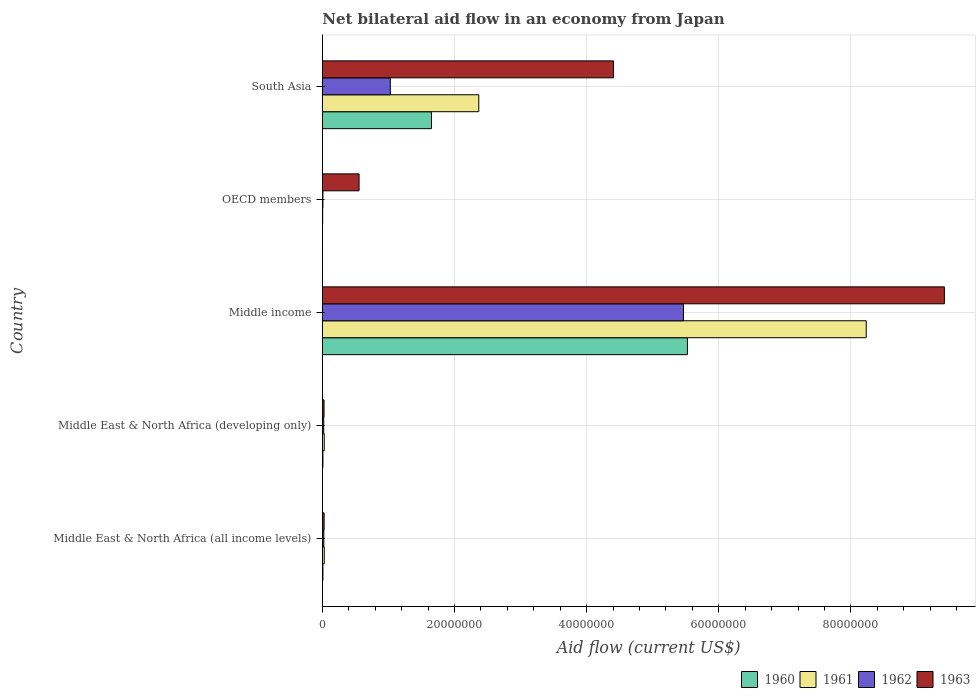How many groups of bars are there?
Keep it short and to the point. 5. Are the number of bars per tick equal to the number of legend labels?
Offer a very short reply. Yes. Are the number of bars on each tick of the Y-axis equal?
Keep it short and to the point. Yes. What is the label of the 4th group of bars from the top?
Give a very brief answer. Middle East & North Africa (developing only). Across all countries, what is the maximum net bilateral aid flow in 1963?
Your response must be concise. 9.42e+07. In which country was the net bilateral aid flow in 1960 maximum?
Give a very brief answer. Middle income. In which country was the net bilateral aid flow in 1963 minimum?
Give a very brief answer. Middle East & North Africa (developing only). What is the total net bilateral aid flow in 1962 in the graph?
Make the answer very short. 6.55e+07. What is the difference between the net bilateral aid flow in 1962 in Middle East & North Africa (all income levels) and that in Middle income?
Offer a terse response. -5.44e+07. What is the difference between the net bilateral aid flow in 1963 in OECD members and the net bilateral aid flow in 1960 in Middle income?
Provide a short and direct response. -4.97e+07. What is the average net bilateral aid flow in 1963 per country?
Offer a terse response. 2.89e+07. What is the difference between the net bilateral aid flow in 1960 and net bilateral aid flow in 1961 in Middle income?
Give a very brief answer. -2.71e+07. In how many countries, is the net bilateral aid flow in 1962 greater than 36000000 US$?
Offer a very short reply. 1. What is the ratio of the net bilateral aid flow in 1961 in Middle East & North Africa (developing only) to that in Middle income?
Keep it short and to the point. 0. Is the net bilateral aid flow in 1962 in Middle East & North Africa (all income levels) less than that in Middle income?
Keep it short and to the point. Yes. What is the difference between the highest and the second highest net bilateral aid flow in 1960?
Your response must be concise. 3.87e+07. What is the difference between the highest and the lowest net bilateral aid flow in 1963?
Provide a succinct answer. 9.39e+07. Is the sum of the net bilateral aid flow in 1963 in Middle income and OECD members greater than the maximum net bilateral aid flow in 1960 across all countries?
Your answer should be compact. Yes. Is it the case that in every country, the sum of the net bilateral aid flow in 1960 and net bilateral aid flow in 1961 is greater than the net bilateral aid flow in 1962?
Give a very brief answer. No. Does the graph contain grids?
Provide a succinct answer. Yes. Where does the legend appear in the graph?
Your response must be concise. Bottom right. How many legend labels are there?
Give a very brief answer. 4. What is the title of the graph?
Keep it short and to the point. Net bilateral aid flow in an economy from Japan. Does "1995" appear as one of the legend labels in the graph?
Provide a short and direct response. No. What is the label or title of the X-axis?
Offer a very short reply. Aid flow (current US$). What is the Aid flow (current US$) of 1960 in Middle East & North Africa (all income levels)?
Offer a terse response. 9.00e+04. What is the Aid flow (current US$) in 1961 in Middle East & North Africa (all income levels)?
Make the answer very short. 2.90e+05. What is the Aid flow (current US$) in 1962 in Middle East & North Africa (all income levels)?
Offer a terse response. 2.30e+05. What is the Aid flow (current US$) in 1963 in Middle East & North Africa (all income levels)?
Keep it short and to the point. 2.70e+05. What is the Aid flow (current US$) of 1962 in Middle East & North Africa (developing only)?
Provide a succinct answer. 2.10e+05. What is the Aid flow (current US$) of 1963 in Middle East & North Africa (developing only)?
Offer a terse response. 2.60e+05. What is the Aid flow (current US$) in 1960 in Middle income?
Give a very brief answer. 5.53e+07. What is the Aid flow (current US$) of 1961 in Middle income?
Give a very brief answer. 8.23e+07. What is the Aid flow (current US$) of 1962 in Middle income?
Provide a succinct answer. 5.47e+07. What is the Aid flow (current US$) in 1963 in Middle income?
Give a very brief answer. 9.42e+07. What is the Aid flow (current US$) in 1960 in OECD members?
Your response must be concise. 3.00e+04. What is the Aid flow (current US$) of 1963 in OECD members?
Offer a terse response. 5.56e+06. What is the Aid flow (current US$) of 1960 in South Asia?
Provide a short and direct response. 1.65e+07. What is the Aid flow (current US$) in 1961 in South Asia?
Provide a succinct answer. 2.37e+07. What is the Aid flow (current US$) of 1962 in South Asia?
Make the answer very short. 1.03e+07. What is the Aid flow (current US$) in 1963 in South Asia?
Keep it short and to the point. 4.41e+07. Across all countries, what is the maximum Aid flow (current US$) in 1960?
Keep it short and to the point. 5.53e+07. Across all countries, what is the maximum Aid flow (current US$) in 1961?
Make the answer very short. 8.23e+07. Across all countries, what is the maximum Aid flow (current US$) of 1962?
Your response must be concise. 5.47e+07. Across all countries, what is the maximum Aid flow (current US$) of 1963?
Ensure brevity in your answer.  9.42e+07. Across all countries, what is the minimum Aid flow (current US$) of 1962?
Ensure brevity in your answer.  9.00e+04. Across all countries, what is the minimum Aid flow (current US$) of 1963?
Ensure brevity in your answer.  2.60e+05. What is the total Aid flow (current US$) in 1960 in the graph?
Ensure brevity in your answer.  7.20e+07. What is the total Aid flow (current US$) of 1961 in the graph?
Ensure brevity in your answer.  1.07e+08. What is the total Aid flow (current US$) in 1962 in the graph?
Give a very brief answer. 6.55e+07. What is the total Aid flow (current US$) of 1963 in the graph?
Offer a terse response. 1.44e+08. What is the difference between the Aid flow (current US$) in 1963 in Middle East & North Africa (all income levels) and that in Middle East & North Africa (developing only)?
Provide a short and direct response. 10000. What is the difference between the Aid flow (current US$) in 1960 in Middle East & North Africa (all income levels) and that in Middle income?
Keep it short and to the point. -5.52e+07. What is the difference between the Aid flow (current US$) of 1961 in Middle East & North Africa (all income levels) and that in Middle income?
Provide a succinct answer. -8.20e+07. What is the difference between the Aid flow (current US$) of 1962 in Middle East & North Africa (all income levels) and that in Middle income?
Your answer should be compact. -5.44e+07. What is the difference between the Aid flow (current US$) in 1963 in Middle East & North Africa (all income levels) and that in Middle income?
Your answer should be compact. -9.39e+07. What is the difference between the Aid flow (current US$) of 1962 in Middle East & North Africa (all income levels) and that in OECD members?
Your response must be concise. 1.40e+05. What is the difference between the Aid flow (current US$) in 1963 in Middle East & North Africa (all income levels) and that in OECD members?
Provide a short and direct response. -5.29e+06. What is the difference between the Aid flow (current US$) of 1960 in Middle East & North Africa (all income levels) and that in South Asia?
Your answer should be compact. -1.64e+07. What is the difference between the Aid flow (current US$) in 1961 in Middle East & North Africa (all income levels) and that in South Asia?
Provide a short and direct response. -2.34e+07. What is the difference between the Aid flow (current US$) in 1962 in Middle East & North Africa (all income levels) and that in South Asia?
Your answer should be compact. -1.01e+07. What is the difference between the Aid flow (current US$) of 1963 in Middle East & North Africa (all income levels) and that in South Asia?
Give a very brief answer. -4.38e+07. What is the difference between the Aid flow (current US$) in 1960 in Middle East & North Africa (developing only) and that in Middle income?
Give a very brief answer. -5.52e+07. What is the difference between the Aid flow (current US$) in 1961 in Middle East & North Africa (developing only) and that in Middle income?
Give a very brief answer. -8.20e+07. What is the difference between the Aid flow (current US$) of 1962 in Middle East & North Africa (developing only) and that in Middle income?
Your answer should be compact. -5.44e+07. What is the difference between the Aid flow (current US$) of 1963 in Middle East & North Africa (developing only) and that in Middle income?
Provide a short and direct response. -9.39e+07. What is the difference between the Aid flow (current US$) of 1961 in Middle East & North Africa (developing only) and that in OECD members?
Provide a short and direct response. 2.40e+05. What is the difference between the Aid flow (current US$) in 1963 in Middle East & North Africa (developing only) and that in OECD members?
Your answer should be very brief. -5.30e+06. What is the difference between the Aid flow (current US$) of 1960 in Middle East & North Africa (developing only) and that in South Asia?
Keep it short and to the point. -1.64e+07. What is the difference between the Aid flow (current US$) in 1961 in Middle East & North Africa (developing only) and that in South Asia?
Ensure brevity in your answer.  -2.34e+07. What is the difference between the Aid flow (current US$) in 1962 in Middle East & North Africa (developing only) and that in South Asia?
Make the answer very short. -1.01e+07. What is the difference between the Aid flow (current US$) of 1963 in Middle East & North Africa (developing only) and that in South Asia?
Provide a succinct answer. -4.38e+07. What is the difference between the Aid flow (current US$) of 1960 in Middle income and that in OECD members?
Your response must be concise. 5.52e+07. What is the difference between the Aid flow (current US$) in 1961 in Middle income and that in OECD members?
Offer a very short reply. 8.23e+07. What is the difference between the Aid flow (current US$) of 1962 in Middle income and that in OECD members?
Keep it short and to the point. 5.46e+07. What is the difference between the Aid flow (current US$) in 1963 in Middle income and that in OECD members?
Provide a succinct answer. 8.86e+07. What is the difference between the Aid flow (current US$) in 1960 in Middle income and that in South Asia?
Your response must be concise. 3.87e+07. What is the difference between the Aid flow (current US$) of 1961 in Middle income and that in South Asia?
Your answer should be compact. 5.86e+07. What is the difference between the Aid flow (current US$) in 1962 in Middle income and that in South Asia?
Offer a very short reply. 4.44e+07. What is the difference between the Aid flow (current US$) in 1963 in Middle income and that in South Asia?
Your response must be concise. 5.01e+07. What is the difference between the Aid flow (current US$) in 1960 in OECD members and that in South Asia?
Provide a succinct answer. -1.65e+07. What is the difference between the Aid flow (current US$) of 1961 in OECD members and that in South Asia?
Your response must be concise. -2.36e+07. What is the difference between the Aid flow (current US$) in 1962 in OECD members and that in South Asia?
Give a very brief answer. -1.02e+07. What is the difference between the Aid flow (current US$) in 1963 in OECD members and that in South Asia?
Provide a succinct answer. -3.85e+07. What is the difference between the Aid flow (current US$) in 1960 in Middle East & North Africa (all income levels) and the Aid flow (current US$) in 1961 in Middle East & North Africa (developing only)?
Your answer should be very brief. -2.00e+05. What is the difference between the Aid flow (current US$) of 1960 in Middle East & North Africa (all income levels) and the Aid flow (current US$) of 1962 in Middle East & North Africa (developing only)?
Make the answer very short. -1.20e+05. What is the difference between the Aid flow (current US$) of 1961 in Middle East & North Africa (all income levels) and the Aid flow (current US$) of 1962 in Middle East & North Africa (developing only)?
Make the answer very short. 8.00e+04. What is the difference between the Aid flow (current US$) in 1962 in Middle East & North Africa (all income levels) and the Aid flow (current US$) in 1963 in Middle East & North Africa (developing only)?
Your response must be concise. -3.00e+04. What is the difference between the Aid flow (current US$) in 1960 in Middle East & North Africa (all income levels) and the Aid flow (current US$) in 1961 in Middle income?
Give a very brief answer. -8.22e+07. What is the difference between the Aid flow (current US$) in 1960 in Middle East & North Africa (all income levels) and the Aid flow (current US$) in 1962 in Middle income?
Ensure brevity in your answer.  -5.46e+07. What is the difference between the Aid flow (current US$) in 1960 in Middle East & North Africa (all income levels) and the Aid flow (current US$) in 1963 in Middle income?
Give a very brief answer. -9.41e+07. What is the difference between the Aid flow (current US$) in 1961 in Middle East & North Africa (all income levels) and the Aid flow (current US$) in 1962 in Middle income?
Your response must be concise. -5.44e+07. What is the difference between the Aid flow (current US$) in 1961 in Middle East & North Africa (all income levels) and the Aid flow (current US$) in 1963 in Middle income?
Offer a terse response. -9.39e+07. What is the difference between the Aid flow (current US$) of 1962 in Middle East & North Africa (all income levels) and the Aid flow (current US$) of 1963 in Middle income?
Provide a succinct answer. -9.39e+07. What is the difference between the Aid flow (current US$) of 1960 in Middle East & North Africa (all income levels) and the Aid flow (current US$) of 1961 in OECD members?
Your response must be concise. 4.00e+04. What is the difference between the Aid flow (current US$) in 1960 in Middle East & North Africa (all income levels) and the Aid flow (current US$) in 1963 in OECD members?
Provide a short and direct response. -5.47e+06. What is the difference between the Aid flow (current US$) in 1961 in Middle East & North Africa (all income levels) and the Aid flow (current US$) in 1962 in OECD members?
Provide a short and direct response. 2.00e+05. What is the difference between the Aid flow (current US$) of 1961 in Middle East & North Africa (all income levels) and the Aid flow (current US$) of 1963 in OECD members?
Ensure brevity in your answer.  -5.27e+06. What is the difference between the Aid flow (current US$) in 1962 in Middle East & North Africa (all income levels) and the Aid flow (current US$) in 1963 in OECD members?
Your response must be concise. -5.33e+06. What is the difference between the Aid flow (current US$) in 1960 in Middle East & North Africa (all income levels) and the Aid flow (current US$) in 1961 in South Asia?
Make the answer very short. -2.36e+07. What is the difference between the Aid flow (current US$) of 1960 in Middle East & North Africa (all income levels) and the Aid flow (current US$) of 1962 in South Asia?
Provide a short and direct response. -1.02e+07. What is the difference between the Aid flow (current US$) in 1960 in Middle East & North Africa (all income levels) and the Aid flow (current US$) in 1963 in South Asia?
Keep it short and to the point. -4.40e+07. What is the difference between the Aid flow (current US$) in 1961 in Middle East & North Africa (all income levels) and the Aid flow (current US$) in 1962 in South Asia?
Your answer should be compact. -1.00e+07. What is the difference between the Aid flow (current US$) of 1961 in Middle East & North Africa (all income levels) and the Aid flow (current US$) of 1963 in South Asia?
Your answer should be very brief. -4.38e+07. What is the difference between the Aid flow (current US$) in 1962 in Middle East & North Africa (all income levels) and the Aid flow (current US$) in 1963 in South Asia?
Your answer should be compact. -4.38e+07. What is the difference between the Aid flow (current US$) in 1960 in Middle East & North Africa (developing only) and the Aid flow (current US$) in 1961 in Middle income?
Your response must be concise. -8.22e+07. What is the difference between the Aid flow (current US$) of 1960 in Middle East & North Africa (developing only) and the Aid flow (current US$) of 1962 in Middle income?
Your answer should be compact. -5.46e+07. What is the difference between the Aid flow (current US$) in 1960 in Middle East & North Africa (developing only) and the Aid flow (current US$) in 1963 in Middle income?
Offer a very short reply. -9.41e+07. What is the difference between the Aid flow (current US$) of 1961 in Middle East & North Africa (developing only) and the Aid flow (current US$) of 1962 in Middle income?
Ensure brevity in your answer.  -5.44e+07. What is the difference between the Aid flow (current US$) in 1961 in Middle East & North Africa (developing only) and the Aid flow (current US$) in 1963 in Middle income?
Offer a very short reply. -9.39e+07. What is the difference between the Aid flow (current US$) in 1962 in Middle East & North Africa (developing only) and the Aid flow (current US$) in 1963 in Middle income?
Keep it short and to the point. -9.39e+07. What is the difference between the Aid flow (current US$) in 1960 in Middle East & North Africa (developing only) and the Aid flow (current US$) in 1962 in OECD members?
Offer a very short reply. 0. What is the difference between the Aid flow (current US$) in 1960 in Middle East & North Africa (developing only) and the Aid flow (current US$) in 1963 in OECD members?
Ensure brevity in your answer.  -5.47e+06. What is the difference between the Aid flow (current US$) in 1961 in Middle East & North Africa (developing only) and the Aid flow (current US$) in 1962 in OECD members?
Offer a very short reply. 2.00e+05. What is the difference between the Aid flow (current US$) in 1961 in Middle East & North Africa (developing only) and the Aid flow (current US$) in 1963 in OECD members?
Give a very brief answer. -5.27e+06. What is the difference between the Aid flow (current US$) of 1962 in Middle East & North Africa (developing only) and the Aid flow (current US$) of 1963 in OECD members?
Keep it short and to the point. -5.35e+06. What is the difference between the Aid flow (current US$) in 1960 in Middle East & North Africa (developing only) and the Aid flow (current US$) in 1961 in South Asia?
Give a very brief answer. -2.36e+07. What is the difference between the Aid flow (current US$) in 1960 in Middle East & North Africa (developing only) and the Aid flow (current US$) in 1962 in South Asia?
Your answer should be very brief. -1.02e+07. What is the difference between the Aid flow (current US$) in 1960 in Middle East & North Africa (developing only) and the Aid flow (current US$) in 1963 in South Asia?
Make the answer very short. -4.40e+07. What is the difference between the Aid flow (current US$) of 1961 in Middle East & North Africa (developing only) and the Aid flow (current US$) of 1962 in South Asia?
Offer a terse response. -1.00e+07. What is the difference between the Aid flow (current US$) of 1961 in Middle East & North Africa (developing only) and the Aid flow (current US$) of 1963 in South Asia?
Your response must be concise. -4.38e+07. What is the difference between the Aid flow (current US$) of 1962 in Middle East & North Africa (developing only) and the Aid flow (current US$) of 1963 in South Asia?
Make the answer very short. -4.39e+07. What is the difference between the Aid flow (current US$) in 1960 in Middle income and the Aid flow (current US$) in 1961 in OECD members?
Provide a short and direct response. 5.52e+07. What is the difference between the Aid flow (current US$) of 1960 in Middle income and the Aid flow (current US$) of 1962 in OECD members?
Ensure brevity in your answer.  5.52e+07. What is the difference between the Aid flow (current US$) of 1960 in Middle income and the Aid flow (current US$) of 1963 in OECD members?
Give a very brief answer. 4.97e+07. What is the difference between the Aid flow (current US$) of 1961 in Middle income and the Aid flow (current US$) of 1962 in OECD members?
Your answer should be very brief. 8.22e+07. What is the difference between the Aid flow (current US$) in 1961 in Middle income and the Aid flow (current US$) in 1963 in OECD members?
Make the answer very short. 7.68e+07. What is the difference between the Aid flow (current US$) in 1962 in Middle income and the Aid flow (current US$) in 1963 in OECD members?
Offer a terse response. 4.91e+07. What is the difference between the Aid flow (current US$) in 1960 in Middle income and the Aid flow (current US$) in 1961 in South Asia?
Give a very brief answer. 3.16e+07. What is the difference between the Aid flow (current US$) of 1960 in Middle income and the Aid flow (current US$) of 1962 in South Asia?
Ensure brevity in your answer.  4.50e+07. What is the difference between the Aid flow (current US$) in 1960 in Middle income and the Aid flow (current US$) in 1963 in South Asia?
Your response must be concise. 1.12e+07. What is the difference between the Aid flow (current US$) in 1961 in Middle income and the Aid flow (current US$) in 1962 in South Asia?
Give a very brief answer. 7.20e+07. What is the difference between the Aid flow (current US$) of 1961 in Middle income and the Aid flow (current US$) of 1963 in South Asia?
Offer a very short reply. 3.82e+07. What is the difference between the Aid flow (current US$) of 1962 in Middle income and the Aid flow (current US$) of 1963 in South Asia?
Ensure brevity in your answer.  1.06e+07. What is the difference between the Aid flow (current US$) in 1960 in OECD members and the Aid flow (current US$) in 1961 in South Asia?
Your response must be concise. -2.36e+07. What is the difference between the Aid flow (current US$) in 1960 in OECD members and the Aid flow (current US$) in 1962 in South Asia?
Offer a very short reply. -1.03e+07. What is the difference between the Aid flow (current US$) of 1960 in OECD members and the Aid flow (current US$) of 1963 in South Asia?
Give a very brief answer. -4.40e+07. What is the difference between the Aid flow (current US$) in 1961 in OECD members and the Aid flow (current US$) in 1962 in South Asia?
Provide a short and direct response. -1.02e+07. What is the difference between the Aid flow (current US$) in 1961 in OECD members and the Aid flow (current US$) in 1963 in South Asia?
Make the answer very short. -4.40e+07. What is the difference between the Aid flow (current US$) of 1962 in OECD members and the Aid flow (current US$) of 1963 in South Asia?
Your answer should be compact. -4.40e+07. What is the average Aid flow (current US$) in 1960 per country?
Offer a terse response. 1.44e+07. What is the average Aid flow (current US$) in 1961 per country?
Keep it short and to the point. 2.13e+07. What is the average Aid flow (current US$) in 1962 per country?
Give a very brief answer. 1.31e+07. What is the average Aid flow (current US$) in 1963 per country?
Your response must be concise. 2.89e+07. What is the difference between the Aid flow (current US$) in 1960 and Aid flow (current US$) in 1961 in Middle East & North Africa (all income levels)?
Give a very brief answer. -2.00e+05. What is the difference between the Aid flow (current US$) of 1960 and Aid flow (current US$) of 1961 in Middle East & North Africa (developing only)?
Your response must be concise. -2.00e+05. What is the difference between the Aid flow (current US$) of 1960 and Aid flow (current US$) of 1963 in Middle East & North Africa (developing only)?
Your answer should be compact. -1.70e+05. What is the difference between the Aid flow (current US$) in 1961 and Aid flow (current US$) in 1962 in Middle East & North Africa (developing only)?
Provide a succinct answer. 8.00e+04. What is the difference between the Aid flow (current US$) in 1961 and Aid flow (current US$) in 1963 in Middle East & North Africa (developing only)?
Your response must be concise. 3.00e+04. What is the difference between the Aid flow (current US$) in 1960 and Aid flow (current US$) in 1961 in Middle income?
Make the answer very short. -2.71e+07. What is the difference between the Aid flow (current US$) of 1960 and Aid flow (current US$) of 1962 in Middle income?
Provide a succinct answer. 6.00e+05. What is the difference between the Aid flow (current US$) of 1960 and Aid flow (current US$) of 1963 in Middle income?
Offer a very short reply. -3.89e+07. What is the difference between the Aid flow (current US$) in 1961 and Aid flow (current US$) in 1962 in Middle income?
Offer a terse response. 2.77e+07. What is the difference between the Aid flow (current US$) of 1961 and Aid flow (current US$) of 1963 in Middle income?
Your response must be concise. -1.18e+07. What is the difference between the Aid flow (current US$) in 1962 and Aid flow (current US$) in 1963 in Middle income?
Provide a succinct answer. -3.95e+07. What is the difference between the Aid flow (current US$) in 1960 and Aid flow (current US$) in 1961 in OECD members?
Make the answer very short. -2.00e+04. What is the difference between the Aid flow (current US$) of 1960 and Aid flow (current US$) of 1962 in OECD members?
Keep it short and to the point. -6.00e+04. What is the difference between the Aid flow (current US$) in 1960 and Aid flow (current US$) in 1963 in OECD members?
Offer a terse response. -5.53e+06. What is the difference between the Aid flow (current US$) of 1961 and Aid flow (current US$) of 1962 in OECD members?
Offer a terse response. -4.00e+04. What is the difference between the Aid flow (current US$) of 1961 and Aid flow (current US$) of 1963 in OECD members?
Give a very brief answer. -5.51e+06. What is the difference between the Aid flow (current US$) in 1962 and Aid flow (current US$) in 1963 in OECD members?
Keep it short and to the point. -5.47e+06. What is the difference between the Aid flow (current US$) of 1960 and Aid flow (current US$) of 1961 in South Asia?
Give a very brief answer. -7.16e+06. What is the difference between the Aid flow (current US$) of 1960 and Aid flow (current US$) of 1962 in South Asia?
Offer a very short reply. 6.23e+06. What is the difference between the Aid flow (current US$) of 1960 and Aid flow (current US$) of 1963 in South Asia?
Ensure brevity in your answer.  -2.76e+07. What is the difference between the Aid flow (current US$) of 1961 and Aid flow (current US$) of 1962 in South Asia?
Give a very brief answer. 1.34e+07. What is the difference between the Aid flow (current US$) in 1961 and Aid flow (current US$) in 1963 in South Asia?
Give a very brief answer. -2.04e+07. What is the difference between the Aid flow (current US$) of 1962 and Aid flow (current US$) of 1963 in South Asia?
Offer a very short reply. -3.38e+07. What is the ratio of the Aid flow (current US$) in 1962 in Middle East & North Africa (all income levels) to that in Middle East & North Africa (developing only)?
Keep it short and to the point. 1.1. What is the ratio of the Aid flow (current US$) in 1963 in Middle East & North Africa (all income levels) to that in Middle East & North Africa (developing only)?
Provide a short and direct response. 1.04. What is the ratio of the Aid flow (current US$) of 1960 in Middle East & North Africa (all income levels) to that in Middle income?
Your response must be concise. 0. What is the ratio of the Aid flow (current US$) of 1961 in Middle East & North Africa (all income levels) to that in Middle income?
Make the answer very short. 0. What is the ratio of the Aid flow (current US$) in 1962 in Middle East & North Africa (all income levels) to that in Middle income?
Your response must be concise. 0. What is the ratio of the Aid flow (current US$) of 1963 in Middle East & North Africa (all income levels) to that in Middle income?
Provide a succinct answer. 0. What is the ratio of the Aid flow (current US$) in 1960 in Middle East & North Africa (all income levels) to that in OECD members?
Your answer should be compact. 3. What is the ratio of the Aid flow (current US$) of 1962 in Middle East & North Africa (all income levels) to that in OECD members?
Offer a very short reply. 2.56. What is the ratio of the Aid flow (current US$) of 1963 in Middle East & North Africa (all income levels) to that in OECD members?
Give a very brief answer. 0.05. What is the ratio of the Aid flow (current US$) of 1960 in Middle East & North Africa (all income levels) to that in South Asia?
Your answer should be compact. 0.01. What is the ratio of the Aid flow (current US$) in 1961 in Middle East & North Africa (all income levels) to that in South Asia?
Ensure brevity in your answer.  0.01. What is the ratio of the Aid flow (current US$) in 1962 in Middle East & North Africa (all income levels) to that in South Asia?
Offer a very short reply. 0.02. What is the ratio of the Aid flow (current US$) of 1963 in Middle East & North Africa (all income levels) to that in South Asia?
Provide a short and direct response. 0.01. What is the ratio of the Aid flow (current US$) of 1960 in Middle East & North Africa (developing only) to that in Middle income?
Give a very brief answer. 0. What is the ratio of the Aid flow (current US$) of 1961 in Middle East & North Africa (developing only) to that in Middle income?
Make the answer very short. 0. What is the ratio of the Aid flow (current US$) in 1962 in Middle East & North Africa (developing only) to that in Middle income?
Your answer should be compact. 0. What is the ratio of the Aid flow (current US$) of 1963 in Middle East & North Africa (developing only) to that in Middle income?
Your answer should be very brief. 0. What is the ratio of the Aid flow (current US$) of 1960 in Middle East & North Africa (developing only) to that in OECD members?
Your answer should be compact. 3. What is the ratio of the Aid flow (current US$) in 1962 in Middle East & North Africa (developing only) to that in OECD members?
Ensure brevity in your answer.  2.33. What is the ratio of the Aid flow (current US$) in 1963 in Middle East & North Africa (developing only) to that in OECD members?
Your answer should be compact. 0.05. What is the ratio of the Aid flow (current US$) in 1960 in Middle East & North Africa (developing only) to that in South Asia?
Give a very brief answer. 0.01. What is the ratio of the Aid flow (current US$) in 1961 in Middle East & North Africa (developing only) to that in South Asia?
Make the answer very short. 0.01. What is the ratio of the Aid flow (current US$) in 1962 in Middle East & North Africa (developing only) to that in South Asia?
Your response must be concise. 0.02. What is the ratio of the Aid flow (current US$) of 1963 in Middle East & North Africa (developing only) to that in South Asia?
Keep it short and to the point. 0.01. What is the ratio of the Aid flow (current US$) of 1960 in Middle income to that in OECD members?
Provide a succinct answer. 1842. What is the ratio of the Aid flow (current US$) of 1961 in Middle income to that in OECD members?
Offer a terse response. 1646.4. What is the ratio of the Aid flow (current US$) in 1962 in Middle income to that in OECD members?
Offer a terse response. 607.33. What is the ratio of the Aid flow (current US$) in 1963 in Middle income to that in OECD members?
Your response must be concise. 16.93. What is the ratio of the Aid flow (current US$) in 1960 in Middle income to that in South Asia?
Your answer should be compact. 3.35. What is the ratio of the Aid flow (current US$) in 1961 in Middle income to that in South Asia?
Your response must be concise. 3.48. What is the ratio of the Aid flow (current US$) in 1962 in Middle income to that in South Asia?
Provide a short and direct response. 5.31. What is the ratio of the Aid flow (current US$) in 1963 in Middle income to that in South Asia?
Ensure brevity in your answer.  2.14. What is the ratio of the Aid flow (current US$) of 1960 in OECD members to that in South Asia?
Your answer should be very brief. 0. What is the ratio of the Aid flow (current US$) in 1961 in OECD members to that in South Asia?
Ensure brevity in your answer.  0. What is the ratio of the Aid flow (current US$) in 1962 in OECD members to that in South Asia?
Offer a very short reply. 0.01. What is the ratio of the Aid flow (current US$) of 1963 in OECD members to that in South Asia?
Keep it short and to the point. 0.13. What is the difference between the highest and the second highest Aid flow (current US$) of 1960?
Your answer should be compact. 3.87e+07. What is the difference between the highest and the second highest Aid flow (current US$) in 1961?
Give a very brief answer. 5.86e+07. What is the difference between the highest and the second highest Aid flow (current US$) of 1962?
Ensure brevity in your answer.  4.44e+07. What is the difference between the highest and the second highest Aid flow (current US$) in 1963?
Ensure brevity in your answer.  5.01e+07. What is the difference between the highest and the lowest Aid flow (current US$) of 1960?
Offer a very short reply. 5.52e+07. What is the difference between the highest and the lowest Aid flow (current US$) of 1961?
Offer a very short reply. 8.23e+07. What is the difference between the highest and the lowest Aid flow (current US$) in 1962?
Offer a terse response. 5.46e+07. What is the difference between the highest and the lowest Aid flow (current US$) of 1963?
Provide a succinct answer. 9.39e+07. 